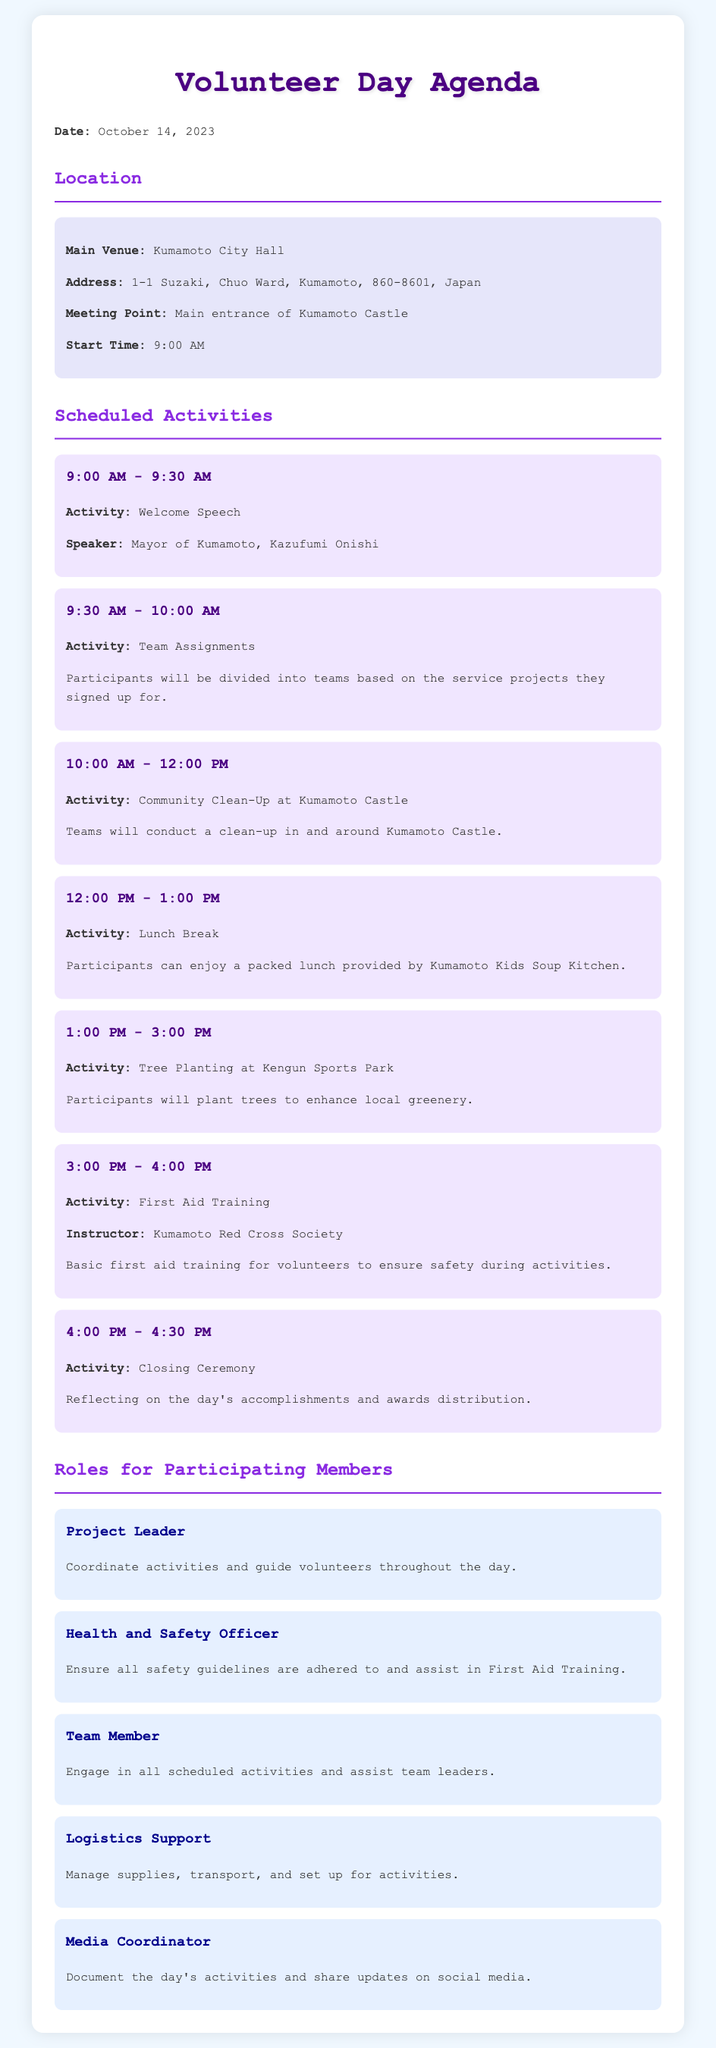what is the date of the Volunteer Day? The date is explicitly mentioned in the agenda as October 14, 2023.
Answer: October 14, 2023 where is the main venue for the Volunteer Day? The main venue for the event is specified in the agenda as Kumamoto City Hall.
Answer: Kumamoto City Hall who will give the welcome speech? The speaker for the welcome speech is identified as the Mayor of Kumamoto, Kazufumi Onishi.
Answer: Kazufumi Onishi what activity occurs from 12:00 PM to 1:00 PM? The agenda outlines that a lunch break is scheduled during this time.
Answer: Lunch Break what role is responsible for coordinating activities? The role designated for coordinating activities is the Project Leader.
Answer: Project Leader how long is the community clean-up activity? The duration of the community clean-up is specified as 2 hours, from 10:00 AM to 12:00 PM.
Answer: 2 hours what is the last activity of the day? The closing ceremony is listed as the final activity in the agenda.
Answer: Closing Ceremony which organization will conduct the first aid training? The first aid training is stated to be led by the Kumamoto Red Cross Society.
Answer: Kumamoto Red Cross Society how many roles are listed for participating members? The agenda details five different roles for participating members.
Answer: Five 